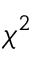Convert formula to latex. <formula><loc_0><loc_0><loc_500><loc_500>\chi ^ { 2 }</formula> 